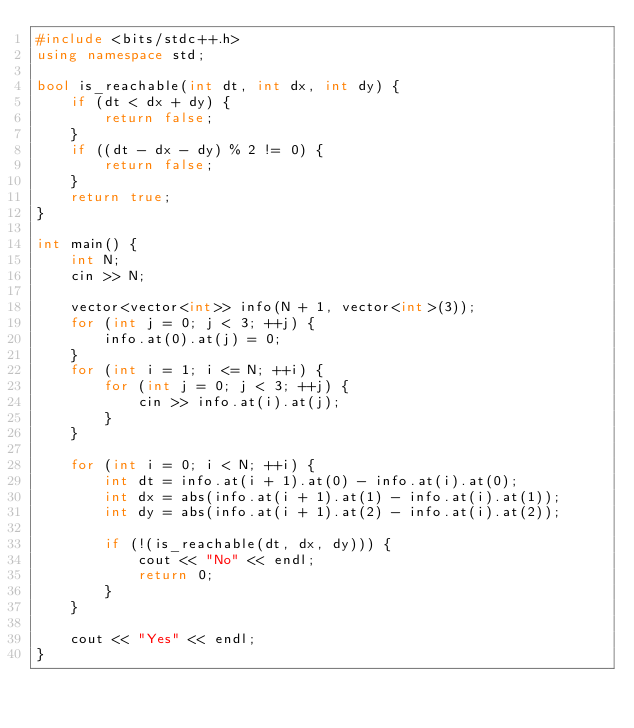<code> <loc_0><loc_0><loc_500><loc_500><_C++_>#include <bits/stdc++.h>
using namespace std;

bool is_reachable(int dt, int dx, int dy) {
    if (dt < dx + dy) {
        return false;
    }
    if ((dt - dx - dy) % 2 != 0) {
        return false;
    }
    return true;
}

int main() {
    int N;
    cin >> N;

    vector<vector<int>> info(N + 1, vector<int>(3));
    for (int j = 0; j < 3; ++j) {
        info.at(0).at(j) = 0;
    }
    for (int i = 1; i <= N; ++i) {
        for (int j = 0; j < 3; ++j) {
            cin >> info.at(i).at(j);
        }
    }

    for (int i = 0; i < N; ++i) {
        int dt = info.at(i + 1).at(0) - info.at(i).at(0);
        int dx = abs(info.at(i + 1).at(1) - info.at(i).at(1));
        int dy = abs(info.at(i + 1).at(2) - info.at(i).at(2));

        if (!(is_reachable(dt, dx, dy))) {
            cout << "No" << endl;
            return 0;
        }
    }

    cout << "Yes" << endl;
}</code> 